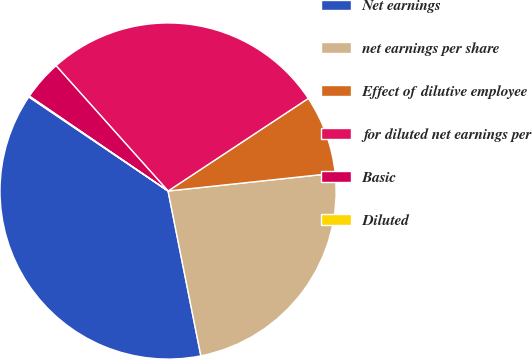Convert chart to OTSL. <chart><loc_0><loc_0><loc_500><loc_500><pie_chart><fcel>Net earnings<fcel>net earnings per share<fcel>Effect of dilutive employee<fcel>for diluted net earnings per<fcel>Basic<fcel>Diluted<nl><fcel>37.58%<fcel>23.57%<fcel>7.59%<fcel>27.32%<fcel>3.84%<fcel>0.09%<nl></chart> 